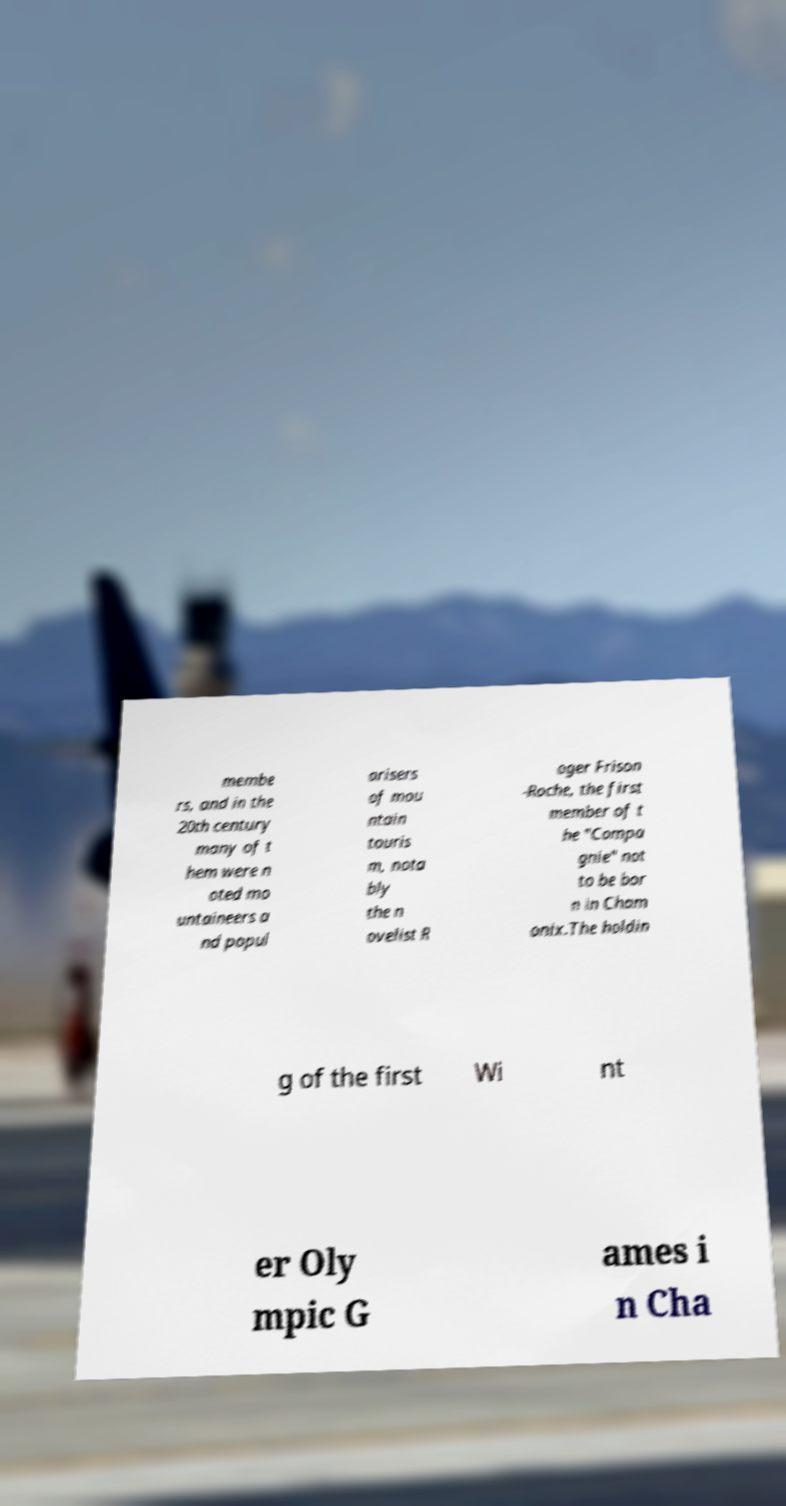Can you accurately transcribe the text from the provided image for me? membe rs, and in the 20th century many of t hem were n oted mo untaineers a nd popul arisers of mou ntain touris m, nota bly the n ovelist R oger Frison -Roche, the first member of t he "Compa gnie" not to be bor n in Cham onix.The holdin g of the first Wi nt er Oly mpic G ames i n Cha 